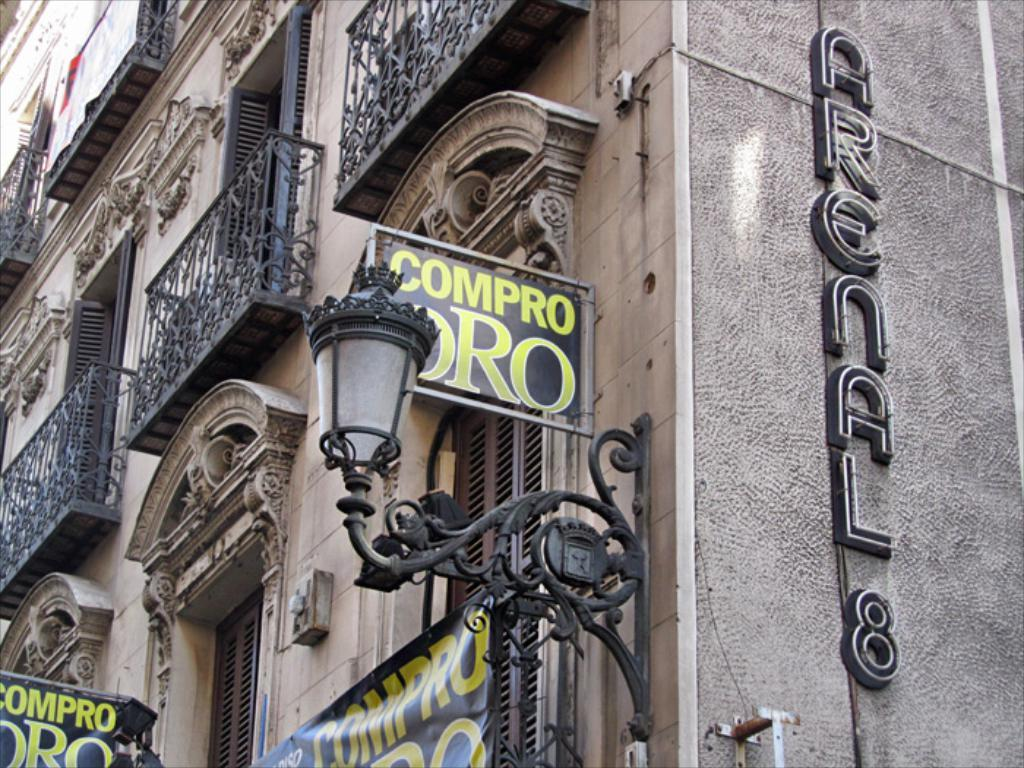What type of structure is visible in the image? There is a building in the image. Does the building have a name or any identifying features? Yes, the building has a name. What other objects can be seen in the image? There are text boards, a banner, and a lantern in the image. How does the hand burn in the image? There is no hand or any indication of burning in the image. 